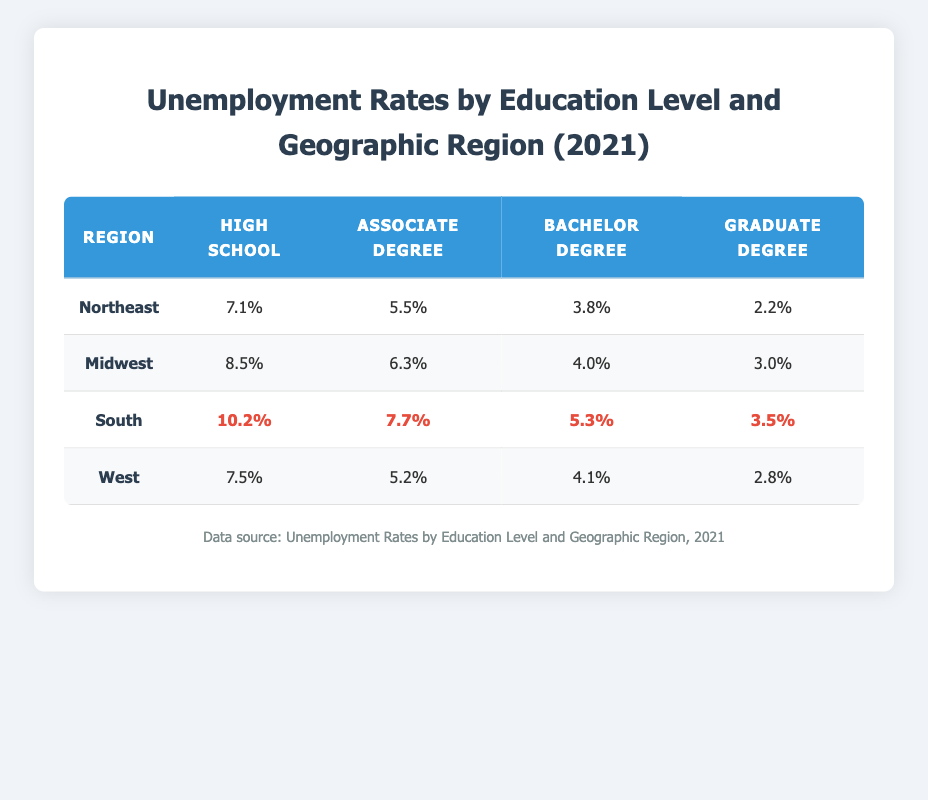What is the unemployment rate for individuals with a high school diploma in the South? The table indicates that the unemployment rate for individuals with a high school diploma in the South is 10.2%.
Answer: 10.2% Which region has the lowest unemployment rate for graduate degree holders? By reviewing the table, we see that the Northeast has the lowest unemployment rate for graduate degree holders at 2.2%.
Answer: Northeast What is the difference in unemployment rates between high school graduates and bachelor degree holders in the Midwest? In the Midwest, the unemployment rate for high school graduates is 8.5%, and for bachelor degree holders, it is 4.0%. The difference is calculated as 8.5% - 4.0% = 4.5%.
Answer: 4.5% Are unemployment rates for high school graduates higher in the South compared to the Northeast? The table shows that the unemployment rate for high school graduates in the South is 10.2%, while in the Northeast, it is 7.1%. Since 10.2% is greater than 7.1%, the statement is true.
Answer: Yes What is the average unemployment rate for associate degree holders across all regions? The unemployment rates for associate degree holders are: Northeast (5.5%), Midwest (6.3%), South (7.7%), and West (5.2%). The average is calculated as (5.5 + 6.3 + 7.7 + 5.2) / 4 = 6.175%.
Answer: 6.175% Which region has the highest unemployment rate for individuals with a bachelor's degree? Reviewing the table, the South displays the highest unemployment rate for bachelor's degree holders at 5.3%.
Answer: South How does the unemployment rate for graduate degree holders in the West compare to that in the Northeast? The table shows that the unemployment rate for graduate degree holders in the West is 2.8%, while in the Northeast it is 2.2%. 2.8% is higher than 2.2%, indicating that the West has a higher rate.
Answer: West What is the total unemployment rate for high school graduates across all regions? The total unemployment rates for high school graduates are 7.1% (Northeast) + 8.5% (Midwest) + 10.2% (South) + 7.5% (West) = 33.3%.
Answer: 33.3% 